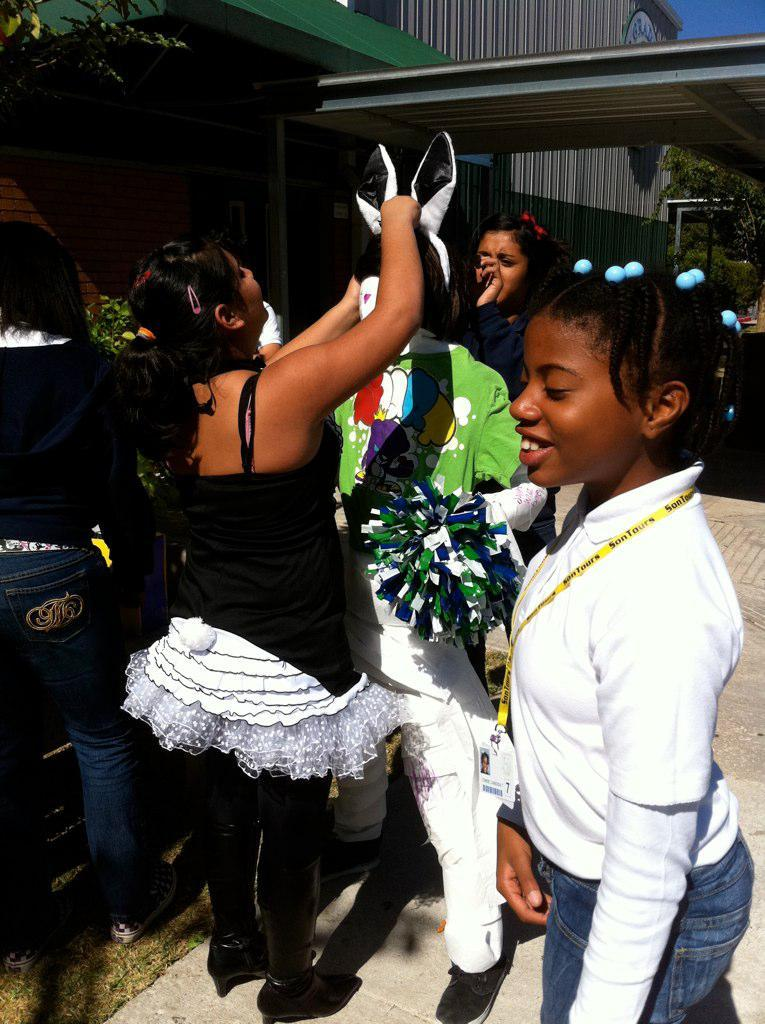What are the people in the image doing? The persons standing on the ground in the image are likely standing or interacting with each other. What can be seen in the distance behind the people? There are trees, a house, and the sky visible in the background of the image. Can you describe the natural environment in the image? The natural environment includes trees and the sky. What type of cork can be seen in the image? There is no cork present in the image. How many toes are visible on the persons in the image? The image does not show the toes of the persons, so it cannot be determined from the image. 